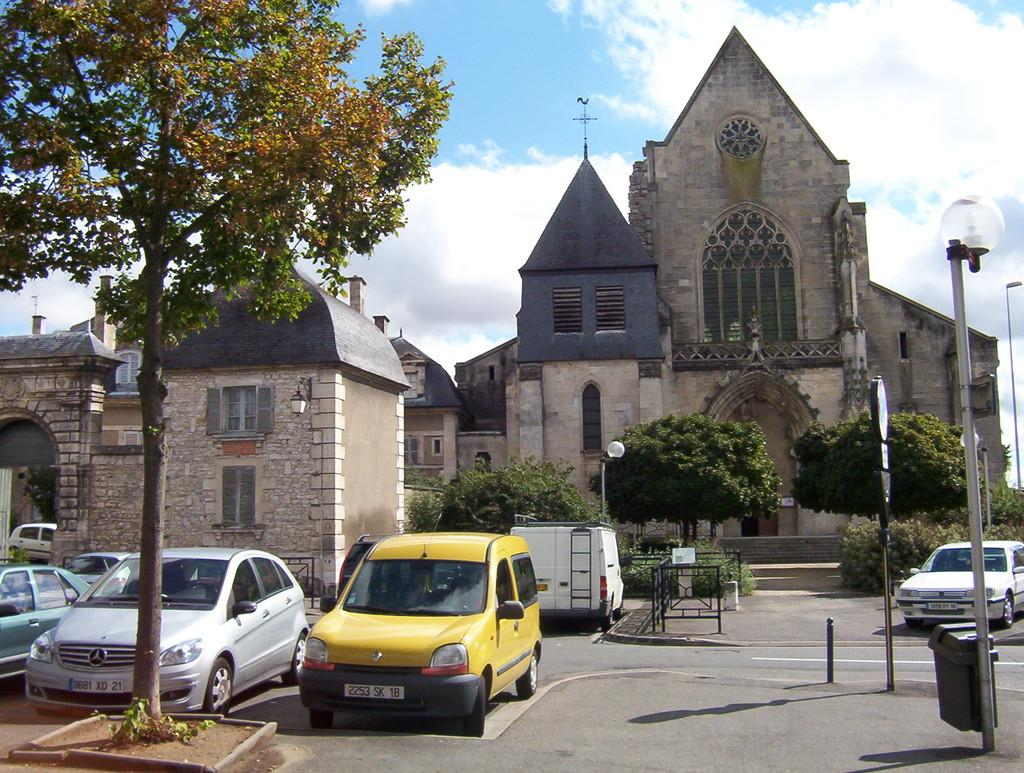What can be seen on the road in the image? There are vehicles on the road in the image. What is located on the left side in the front of the image? There is a tree on the left side in the front of the image. What is visible in the background of the image? There are buildings, trees, and poles in the background of the image. How would you describe the sky in the image? The sky is cloudy in the background of the image. How many mice are sitting on the tree in the image? There are no mice present in the image; it features vehicles on the road, a tree on the left side, and buildings, trees, and poles in the background. What type of iron is being used to support the buildings in the image? There is no iron visible in the image, and the buildings' support structures are not mentioned in the provided facts. 